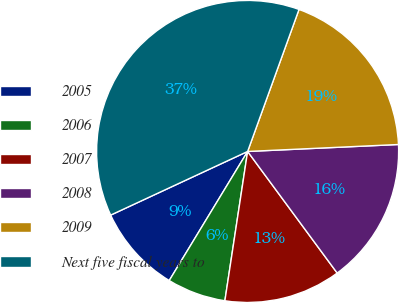Convert chart to OTSL. <chart><loc_0><loc_0><loc_500><loc_500><pie_chart><fcel>2005<fcel>2006<fcel>2007<fcel>2008<fcel>2009<fcel>Next five fiscal years to<nl><fcel>9.39%<fcel>6.28%<fcel>12.51%<fcel>15.63%<fcel>18.74%<fcel>37.45%<nl></chart> 